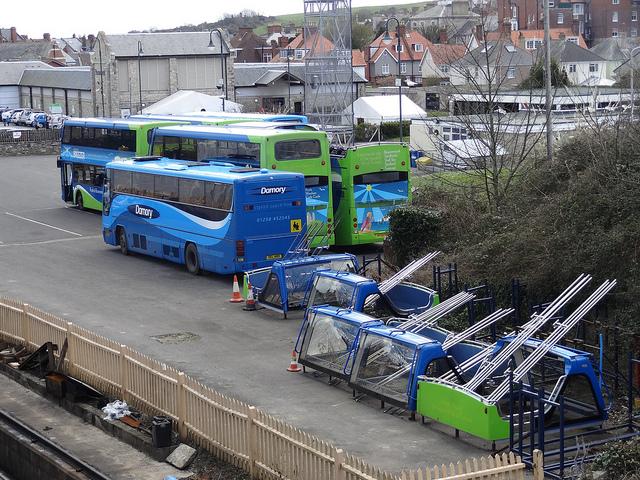What color is the single-story bus?
Quick response, please. Blue. Was the photo taken at an airport?
Quick response, please. No. What is the color of the sky?
Give a very brief answer. White. 